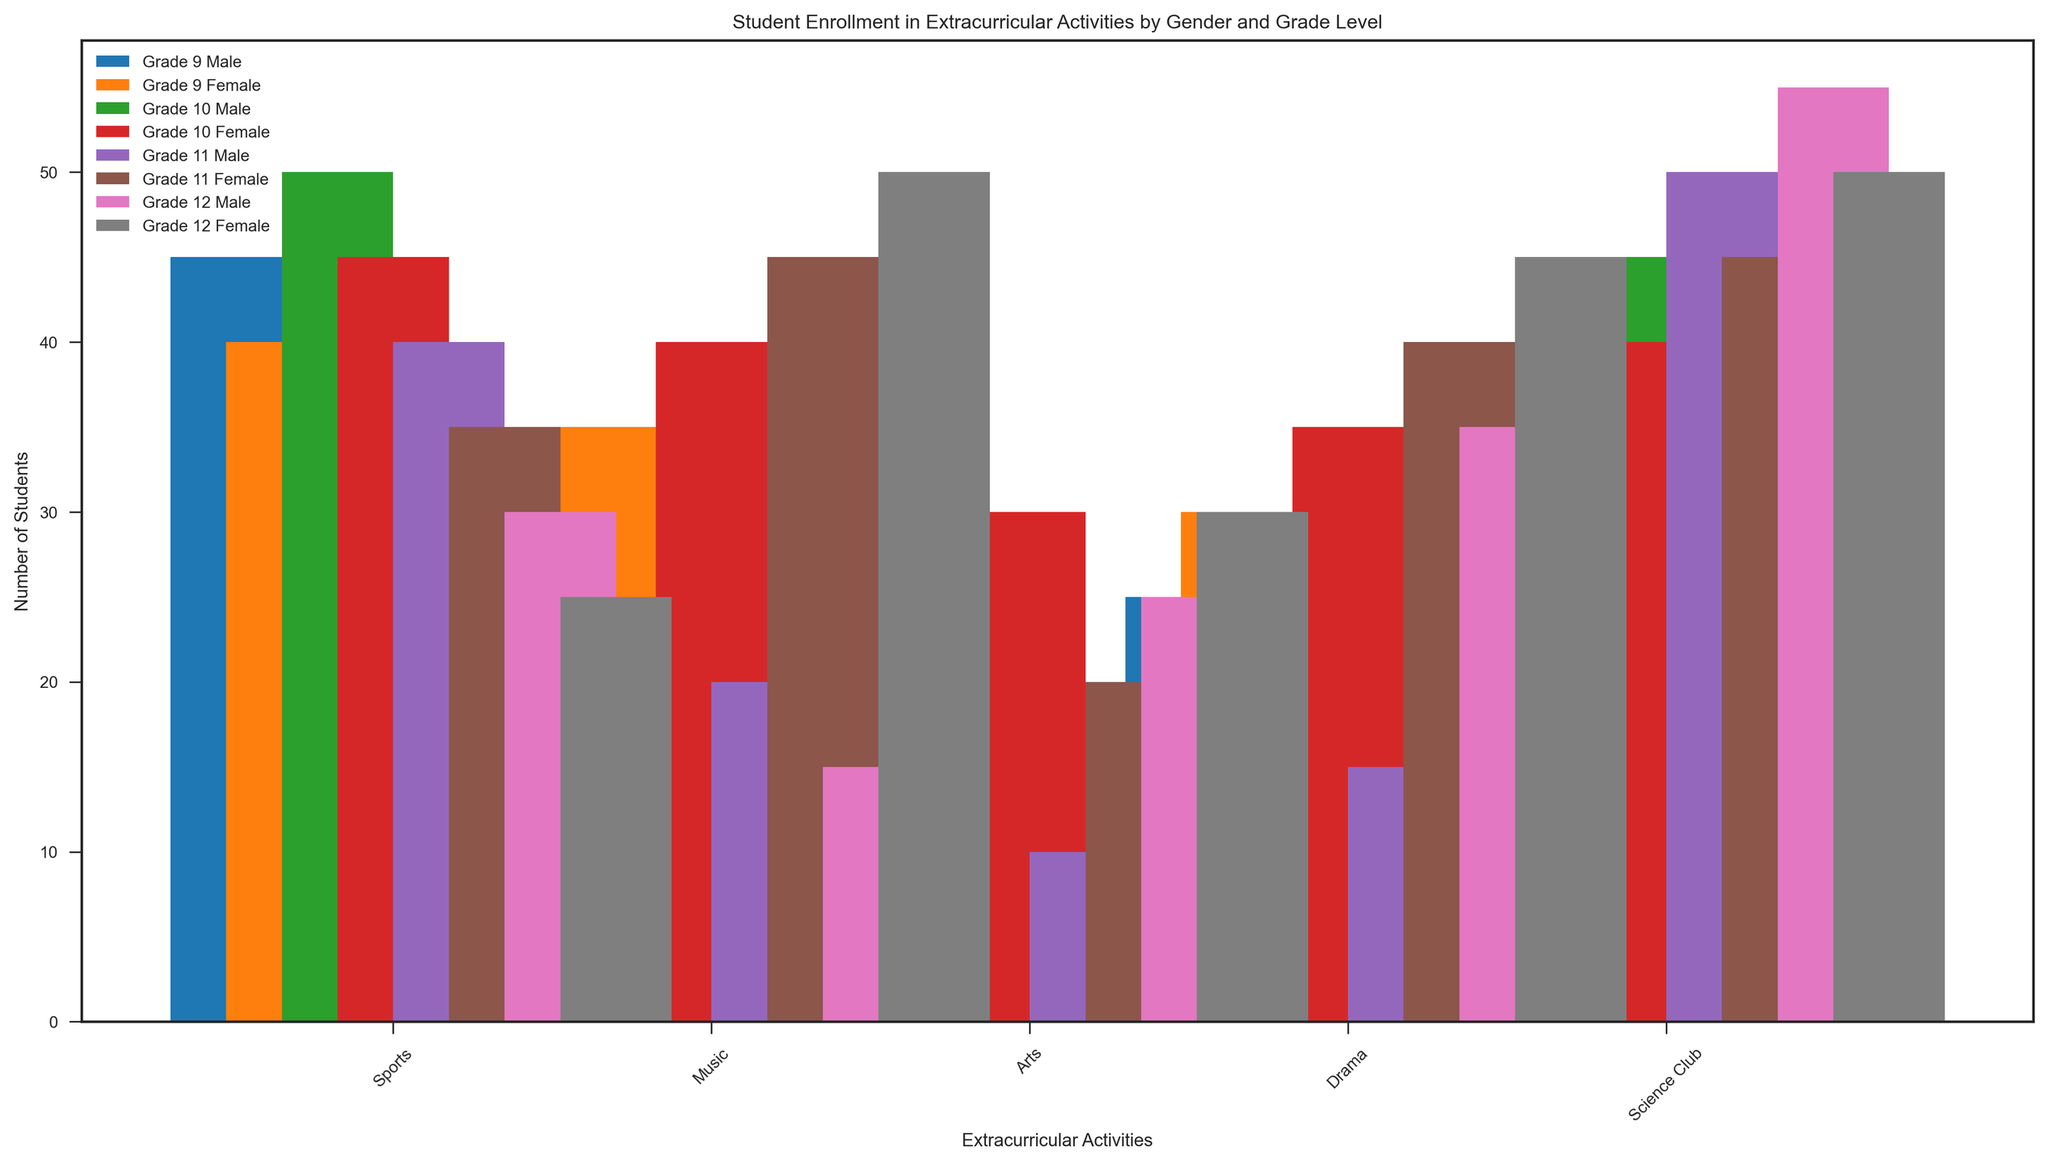Which grade has the highest male enrollment in Science Club? To determine the grade with the highest male enrollment in Science Club, we look at the bars corresponding to the "Science Club" column for males across different grades. Grade 12 males have the highest bar, indicating they have the highest enrollment.
Answer: Grade 12 How many more 11th-grade females are there in Music compared to 11th-grade males? To find the difference in Music enrollment between 11th-grade females and males, we compare the heights of their respective bars in the "Music" column. The number for females is 45, and for males, it is 20. Subtracting these values gives us 25.
Answer: 25 Compare the total enrollment in Drama for 10th graders (both genders). First, determine the number of students enrolled in Drama for both male and female 10th graders by looking at their respective bars in the "Drama" column. Adding 10th-grade males (20) and females (35) gives a total of 55 students.
Answer: 55 Which activity has the closest enrollment numbers between 9th-grade males and females? To identify the activity with the closest enrollment numbers, compare the bars for 9th-grade males and females across all activities. The smallest difference is in "Sports" where males have 45 and females have 40, a difference of 5.
Answer: Sports Which extracurricular activity shows the largest gender disparity in enrollment for 12th graders? To find the activity with the largest gender disparity for 12th graders, compare the male and female bars across all activities. The largest difference is in "Music," where females have 50, and males have 15, providing a disparity of 35.
Answer: Music Sum the total number of students in Arts for all grades (both genders). To calculate the total enrollment in Arts across all grades and genders, sum the values from each category: (20 + 25 + 15 + 30 + 10 + 20 + 25 + 30) = 175.
Answer: 175 Which gender has higher overall participation in extracurricular activities across all grades? By visually summing up the heights of all bars for each gender, it is evident that females generally have higher bars in most categories and grades. Therefore, females have higher participation overall.
Answer: Female What is the average enrollment in Sports for female students across all grades? To find the average enrollment, sum the number of females enrolled in Sports across all grades and divide by the number of grades: (40 + 45 + 35 + 25) / 4 = 145 / 4 = 36.25.
Answer: 36.25 